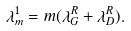<formula> <loc_0><loc_0><loc_500><loc_500>\lambda _ { m } ^ { 1 } = m ( \lambda _ { G } ^ { R } + \lambda _ { D } ^ { R } ) .</formula> 